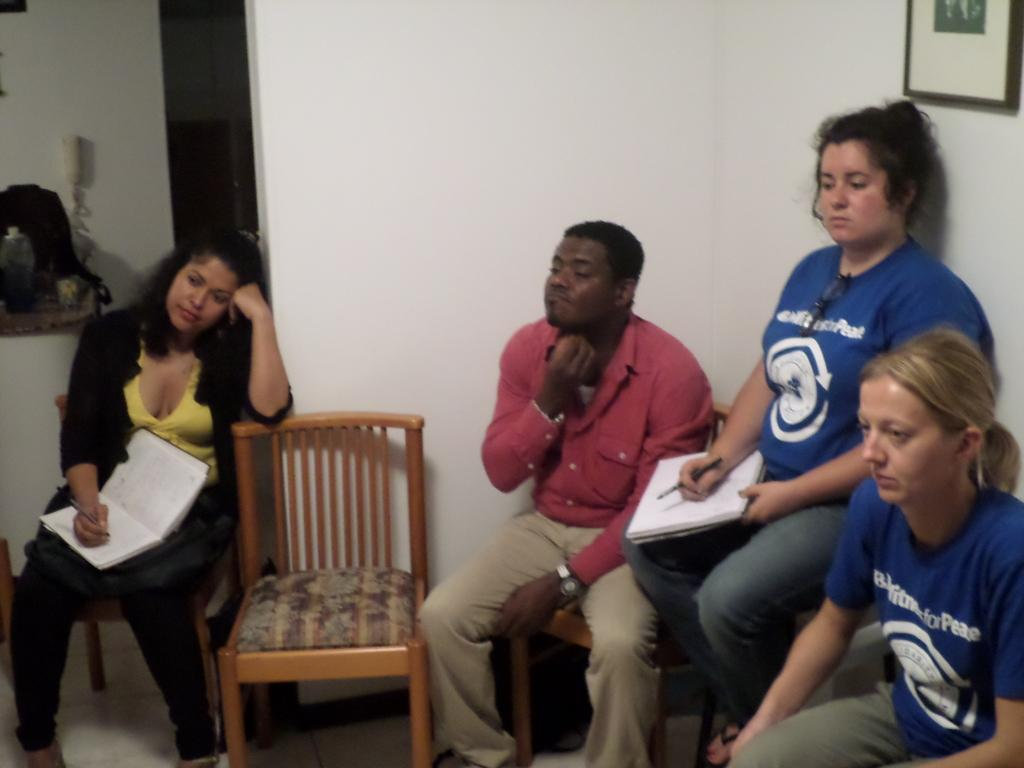What is happening in the image? There is a group of people in the image. What are the people doing in the image? The people are sitting on chairs. Can you describe anything on the wall in the image? There is a photograph on the wall in the image. What is the title of the picture hanging on the wall in the image? There is no title mentioned for the photograph on the wall in the image. How does the picture on the wall twist in the image? The picture on the wall does not twist in the image; it is a still photograph. 